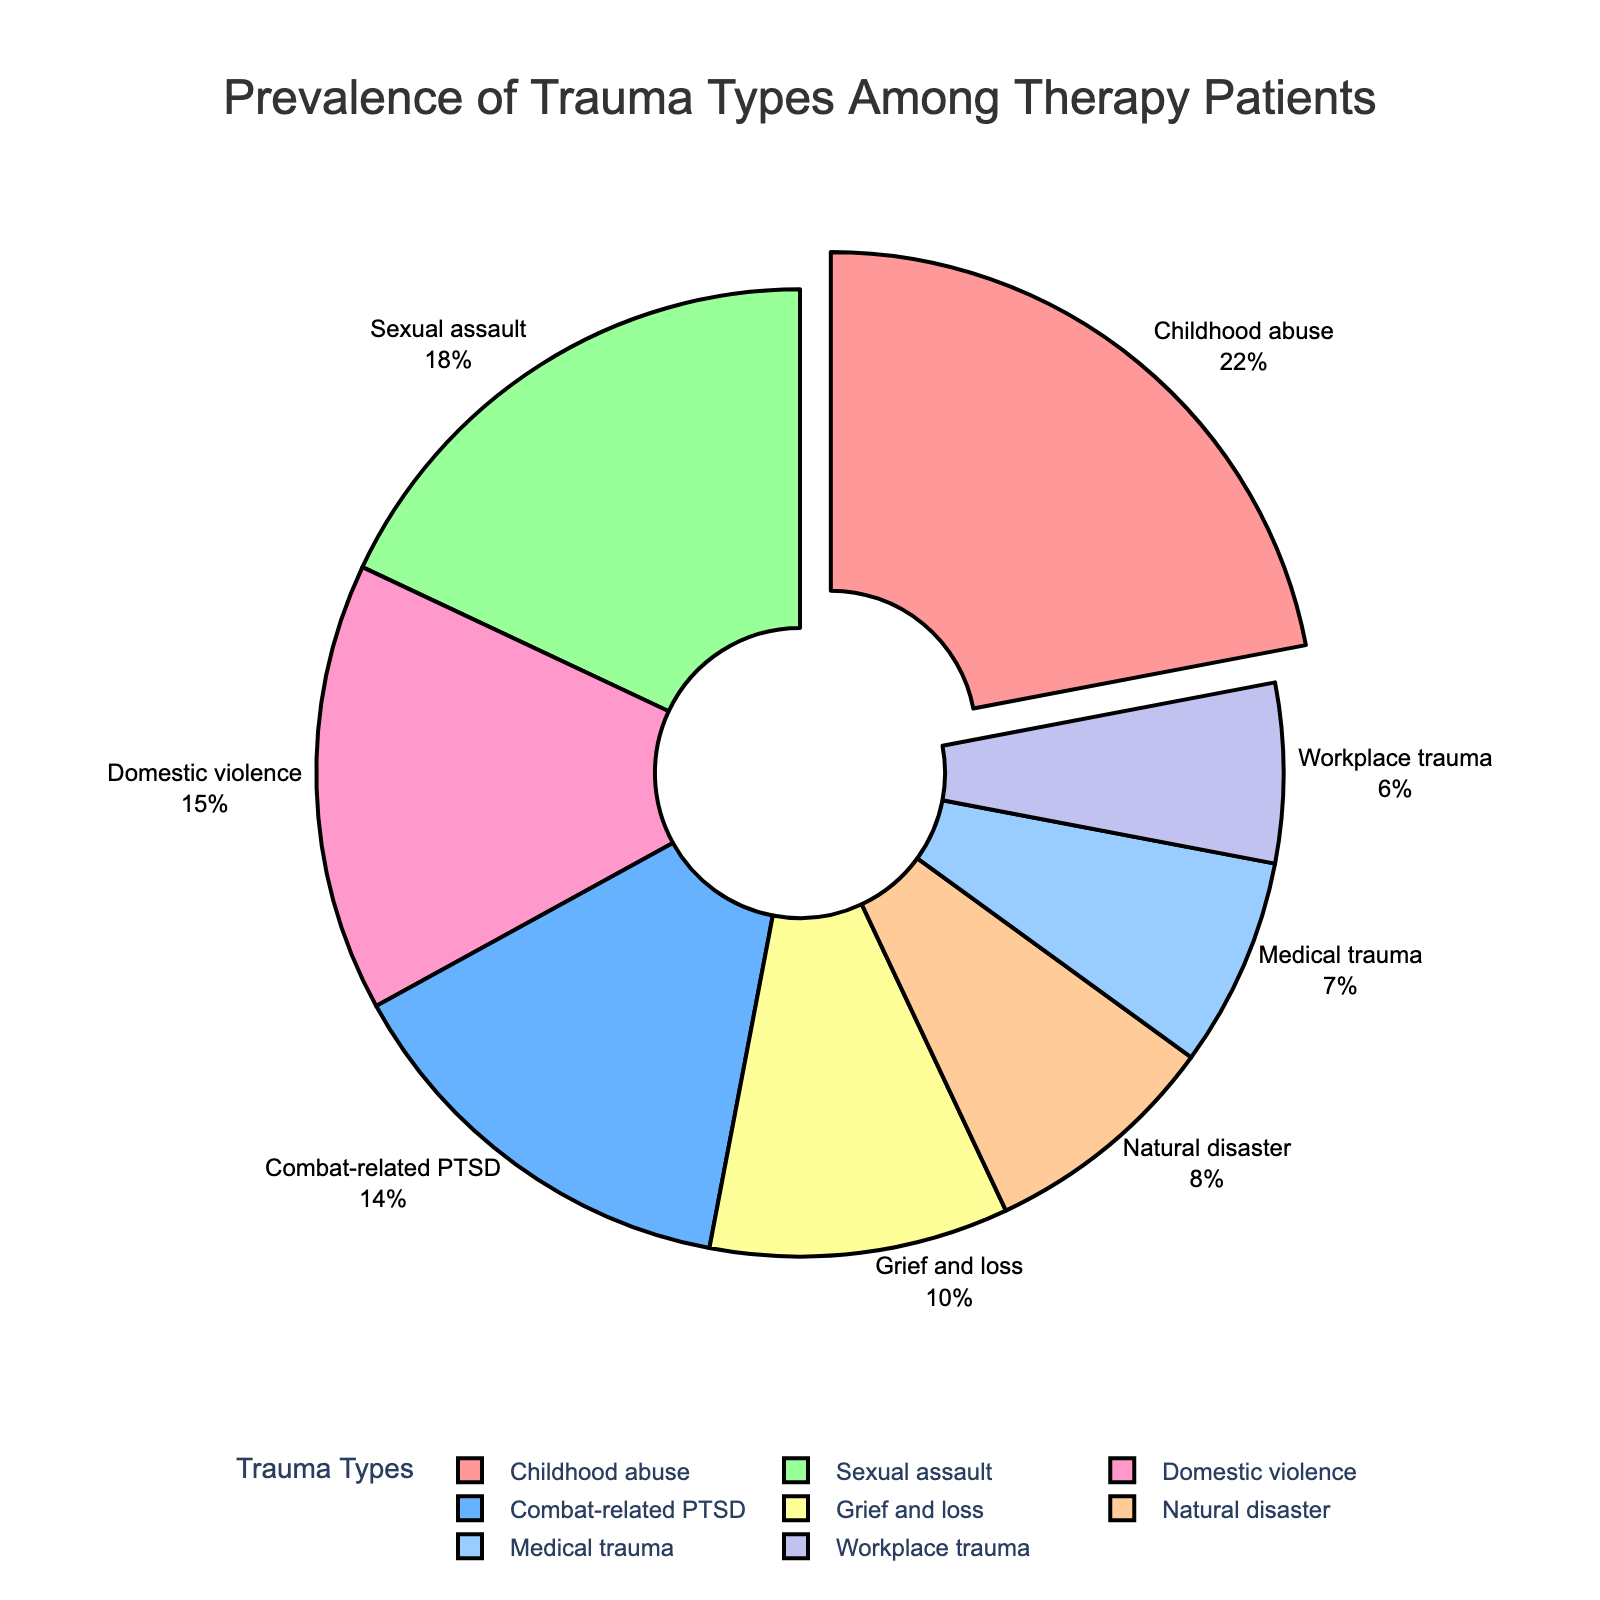Which trauma type is the most prevalent among therapy patients? By looking at the pie chart, the segment pulled slightly away from the center represents the trauma type with the highest percentage. This trauma type is labeled "Childhood abuse."
Answer: Childhood abuse Which trauma type has a larger prevalence, sexual assault or combat-related PTSD? To answer this, compare the percentages represented by both segments. Sexual assault has a higher percentage (18%) than combat-related PTSD (14%).
Answer: Sexual assault What is the combined prevalence of medical trauma and workplace trauma? Add the percentages of both segments: medical trauma (7%) and workplace trauma (6%), which totals 7% + 6% = 13%.
Answer: 13% What is the difference in percentage between domestic violence and grief and loss? Subtract the percentage of grief and loss (10%) from the percentage of domestic violence (15%), resulting in 15% - 10% = 5%.
Answer: 5% Which trauma type has the smallest representation in the pie chart? The segment with the smallest percentage identifies the least prevalent trauma type. This is labeled "Workplace trauma" with 6%.
Answer: Workplace trauma What is the total percentage of trauma types related to interpersonal violence (childhood abuse, domestic violence, and sexual assault)? Add the percentages of childhood abuse (22%), domestic violence (15%), and sexual assault (18%) to get 22% + 15% + 18% = 55%.
Answer: 55% Is the prevalence of natural disaster-related trauma higher or lower than medical trauma? Compare the segments for natural disaster (8%) and medical trauma (7%). Natural disaster-related trauma is higher.
Answer: Higher What visual attribute indicates the most prevalent trauma type in the chart? The pie chart highlights the most prevalent trauma type by slightly pulling its segment away from the center.
Answer: Segment pulled away Which trauma type has a prevalence closer to 20%, grief and loss or domestic violence? Compare the percentages for grief and loss (10%) and domestic violence (15%) and see which is nearer to 20%. Domestic violence is closer.
Answer: Domestic violence 